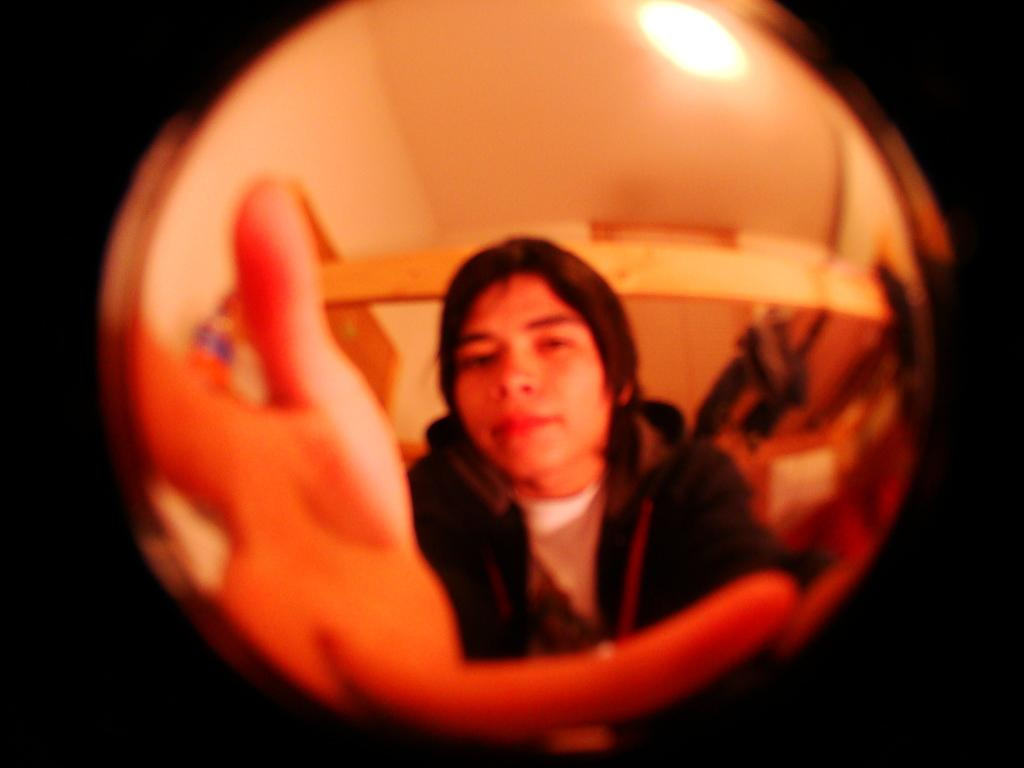Who is present in the image? There is a man in the image. What type of structure can be seen in the image? There is a roof and a wall in the image. What can be used for illumination in the image? There is a light in the image. How would you describe the overall lighting in the image? The background of the image is dark. How many deer can be seen in the image? There are no deer present in the image. What letter is being written by the man in the image? There is no indication that the man is writing a letter in the image. 